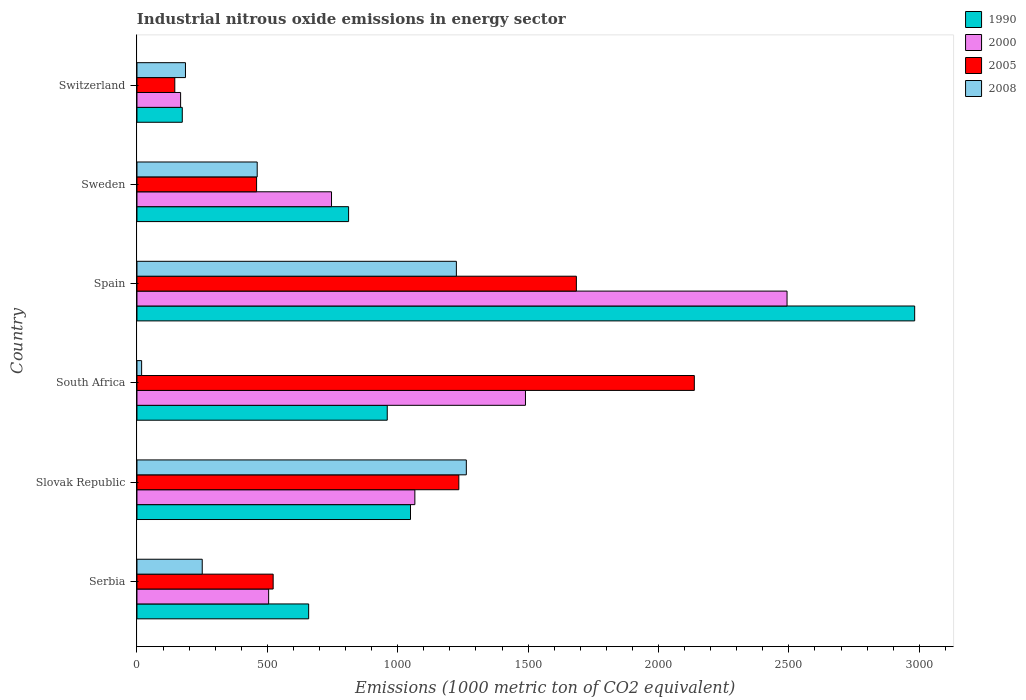How many different coloured bars are there?
Provide a short and direct response. 4. How many groups of bars are there?
Your answer should be very brief. 6. Are the number of bars on each tick of the Y-axis equal?
Keep it short and to the point. Yes. How many bars are there on the 1st tick from the top?
Offer a very short reply. 4. How many bars are there on the 3rd tick from the bottom?
Your answer should be very brief. 4. What is the label of the 1st group of bars from the top?
Give a very brief answer. Switzerland. In how many cases, is the number of bars for a given country not equal to the number of legend labels?
Give a very brief answer. 0. What is the amount of industrial nitrous oxide emitted in 2008 in South Africa?
Offer a terse response. 17.9. Across all countries, what is the maximum amount of industrial nitrous oxide emitted in 2008?
Make the answer very short. 1263.1. Across all countries, what is the minimum amount of industrial nitrous oxide emitted in 1990?
Keep it short and to the point. 173.8. In which country was the amount of industrial nitrous oxide emitted in 2005 maximum?
Give a very brief answer. South Africa. In which country was the amount of industrial nitrous oxide emitted in 2005 minimum?
Offer a terse response. Switzerland. What is the total amount of industrial nitrous oxide emitted in 2005 in the graph?
Offer a very short reply. 6183. What is the difference between the amount of industrial nitrous oxide emitted in 2008 in South Africa and that in Spain?
Provide a succinct answer. -1207. What is the difference between the amount of industrial nitrous oxide emitted in 2005 in Switzerland and the amount of industrial nitrous oxide emitted in 2000 in Spain?
Make the answer very short. -2347.9. What is the average amount of industrial nitrous oxide emitted in 2000 per country?
Offer a terse response. 1077.85. What is the difference between the amount of industrial nitrous oxide emitted in 2000 and amount of industrial nitrous oxide emitted in 2008 in Slovak Republic?
Your answer should be very brief. -197.4. In how many countries, is the amount of industrial nitrous oxide emitted in 2008 greater than 1000 1000 metric ton?
Give a very brief answer. 2. What is the ratio of the amount of industrial nitrous oxide emitted in 1990 in Slovak Republic to that in South Africa?
Make the answer very short. 1.09. Is the difference between the amount of industrial nitrous oxide emitted in 2000 in South Africa and Sweden greater than the difference between the amount of industrial nitrous oxide emitted in 2008 in South Africa and Sweden?
Your answer should be very brief. Yes. What is the difference between the highest and the second highest amount of industrial nitrous oxide emitted in 2000?
Your response must be concise. 1003.1. What is the difference between the highest and the lowest amount of industrial nitrous oxide emitted in 2005?
Provide a succinct answer. 1992.3. In how many countries, is the amount of industrial nitrous oxide emitted in 2000 greater than the average amount of industrial nitrous oxide emitted in 2000 taken over all countries?
Offer a terse response. 2. Is the sum of the amount of industrial nitrous oxide emitted in 1990 in Serbia and Slovak Republic greater than the maximum amount of industrial nitrous oxide emitted in 2005 across all countries?
Provide a succinct answer. No. Is it the case that in every country, the sum of the amount of industrial nitrous oxide emitted in 2000 and amount of industrial nitrous oxide emitted in 2005 is greater than the sum of amount of industrial nitrous oxide emitted in 1990 and amount of industrial nitrous oxide emitted in 2008?
Your answer should be compact. No. What does the 2nd bar from the bottom in Switzerland represents?
Your answer should be very brief. 2000. How many bars are there?
Make the answer very short. 24. How many countries are there in the graph?
Offer a very short reply. 6. What is the difference between two consecutive major ticks on the X-axis?
Ensure brevity in your answer.  500. Does the graph contain grids?
Ensure brevity in your answer.  No. Where does the legend appear in the graph?
Keep it short and to the point. Top right. How many legend labels are there?
Offer a terse response. 4. What is the title of the graph?
Provide a short and direct response. Industrial nitrous oxide emissions in energy sector. What is the label or title of the X-axis?
Offer a very short reply. Emissions (1000 metric ton of CO2 equivalent). What is the label or title of the Y-axis?
Your answer should be compact. Country. What is the Emissions (1000 metric ton of CO2 equivalent) of 1990 in Serbia?
Provide a short and direct response. 658.4. What is the Emissions (1000 metric ton of CO2 equivalent) of 2000 in Serbia?
Offer a very short reply. 505. What is the Emissions (1000 metric ton of CO2 equivalent) in 2005 in Serbia?
Make the answer very short. 522.3. What is the Emissions (1000 metric ton of CO2 equivalent) in 2008 in Serbia?
Your response must be concise. 250.3. What is the Emissions (1000 metric ton of CO2 equivalent) in 1990 in Slovak Republic?
Your answer should be very brief. 1049. What is the Emissions (1000 metric ton of CO2 equivalent) of 2000 in Slovak Republic?
Your answer should be very brief. 1065.7. What is the Emissions (1000 metric ton of CO2 equivalent) in 2005 in Slovak Republic?
Ensure brevity in your answer.  1234.3. What is the Emissions (1000 metric ton of CO2 equivalent) of 2008 in Slovak Republic?
Offer a terse response. 1263.1. What is the Emissions (1000 metric ton of CO2 equivalent) of 1990 in South Africa?
Make the answer very short. 959.8. What is the Emissions (1000 metric ton of CO2 equivalent) of 2000 in South Africa?
Offer a very short reply. 1489.9. What is the Emissions (1000 metric ton of CO2 equivalent) in 2005 in South Africa?
Make the answer very short. 2137.4. What is the Emissions (1000 metric ton of CO2 equivalent) of 2008 in South Africa?
Offer a terse response. 17.9. What is the Emissions (1000 metric ton of CO2 equivalent) of 1990 in Spain?
Offer a terse response. 2982.4. What is the Emissions (1000 metric ton of CO2 equivalent) of 2000 in Spain?
Offer a terse response. 2493. What is the Emissions (1000 metric ton of CO2 equivalent) of 2005 in Spain?
Make the answer very short. 1685.1. What is the Emissions (1000 metric ton of CO2 equivalent) in 2008 in Spain?
Give a very brief answer. 1224.9. What is the Emissions (1000 metric ton of CO2 equivalent) in 1990 in Sweden?
Your response must be concise. 811.6. What is the Emissions (1000 metric ton of CO2 equivalent) in 2000 in Sweden?
Your response must be concise. 746.1. What is the Emissions (1000 metric ton of CO2 equivalent) of 2005 in Sweden?
Offer a terse response. 458.8. What is the Emissions (1000 metric ton of CO2 equivalent) of 2008 in Sweden?
Make the answer very short. 461.1. What is the Emissions (1000 metric ton of CO2 equivalent) in 1990 in Switzerland?
Keep it short and to the point. 173.8. What is the Emissions (1000 metric ton of CO2 equivalent) in 2000 in Switzerland?
Your answer should be very brief. 167.4. What is the Emissions (1000 metric ton of CO2 equivalent) of 2005 in Switzerland?
Your answer should be very brief. 145.1. What is the Emissions (1000 metric ton of CO2 equivalent) in 2008 in Switzerland?
Your response must be concise. 186. Across all countries, what is the maximum Emissions (1000 metric ton of CO2 equivalent) in 1990?
Offer a very short reply. 2982.4. Across all countries, what is the maximum Emissions (1000 metric ton of CO2 equivalent) in 2000?
Your response must be concise. 2493. Across all countries, what is the maximum Emissions (1000 metric ton of CO2 equivalent) in 2005?
Give a very brief answer. 2137.4. Across all countries, what is the maximum Emissions (1000 metric ton of CO2 equivalent) of 2008?
Offer a terse response. 1263.1. Across all countries, what is the minimum Emissions (1000 metric ton of CO2 equivalent) in 1990?
Your response must be concise. 173.8. Across all countries, what is the minimum Emissions (1000 metric ton of CO2 equivalent) of 2000?
Ensure brevity in your answer.  167.4. Across all countries, what is the minimum Emissions (1000 metric ton of CO2 equivalent) of 2005?
Your answer should be very brief. 145.1. What is the total Emissions (1000 metric ton of CO2 equivalent) of 1990 in the graph?
Provide a succinct answer. 6635. What is the total Emissions (1000 metric ton of CO2 equivalent) of 2000 in the graph?
Provide a short and direct response. 6467.1. What is the total Emissions (1000 metric ton of CO2 equivalent) of 2005 in the graph?
Your response must be concise. 6183. What is the total Emissions (1000 metric ton of CO2 equivalent) in 2008 in the graph?
Give a very brief answer. 3403.3. What is the difference between the Emissions (1000 metric ton of CO2 equivalent) of 1990 in Serbia and that in Slovak Republic?
Provide a short and direct response. -390.6. What is the difference between the Emissions (1000 metric ton of CO2 equivalent) of 2000 in Serbia and that in Slovak Republic?
Give a very brief answer. -560.7. What is the difference between the Emissions (1000 metric ton of CO2 equivalent) of 2005 in Serbia and that in Slovak Republic?
Keep it short and to the point. -712. What is the difference between the Emissions (1000 metric ton of CO2 equivalent) in 2008 in Serbia and that in Slovak Republic?
Provide a succinct answer. -1012.8. What is the difference between the Emissions (1000 metric ton of CO2 equivalent) of 1990 in Serbia and that in South Africa?
Make the answer very short. -301.4. What is the difference between the Emissions (1000 metric ton of CO2 equivalent) of 2000 in Serbia and that in South Africa?
Offer a terse response. -984.9. What is the difference between the Emissions (1000 metric ton of CO2 equivalent) in 2005 in Serbia and that in South Africa?
Your answer should be very brief. -1615.1. What is the difference between the Emissions (1000 metric ton of CO2 equivalent) in 2008 in Serbia and that in South Africa?
Your answer should be compact. 232.4. What is the difference between the Emissions (1000 metric ton of CO2 equivalent) of 1990 in Serbia and that in Spain?
Provide a short and direct response. -2324. What is the difference between the Emissions (1000 metric ton of CO2 equivalent) in 2000 in Serbia and that in Spain?
Provide a succinct answer. -1988. What is the difference between the Emissions (1000 metric ton of CO2 equivalent) of 2005 in Serbia and that in Spain?
Ensure brevity in your answer.  -1162.8. What is the difference between the Emissions (1000 metric ton of CO2 equivalent) of 2008 in Serbia and that in Spain?
Ensure brevity in your answer.  -974.6. What is the difference between the Emissions (1000 metric ton of CO2 equivalent) of 1990 in Serbia and that in Sweden?
Your answer should be very brief. -153.2. What is the difference between the Emissions (1000 metric ton of CO2 equivalent) of 2000 in Serbia and that in Sweden?
Give a very brief answer. -241.1. What is the difference between the Emissions (1000 metric ton of CO2 equivalent) of 2005 in Serbia and that in Sweden?
Provide a short and direct response. 63.5. What is the difference between the Emissions (1000 metric ton of CO2 equivalent) of 2008 in Serbia and that in Sweden?
Ensure brevity in your answer.  -210.8. What is the difference between the Emissions (1000 metric ton of CO2 equivalent) of 1990 in Serbia and that in Switzerland?
Provide a succinct answer. 484.6. What is the difference between the Emissions (1000 metric ton of CO2 equivalent) in 2000 in Serbia and that in Switzerland?
Provide a succinct answer. 337.6. What is the difference between the Emissions (1000 metric ton of CO2 equivalent) of 2005 in Serbia and that in Switzerland?
Keep it short and to the point. 377.2. What is the difference between the Emissions (1000 metric ton of CO2 equivalent) of 2008 in Serbia and that in Switzerland?
Your answer should be very brief. 64.3. What is the difference between the Emissions (1000 metric ton of CO2 equivalent) in 1990 in Slovak Republic and that in South Africa?
Your response must be concise. 89.2. What is the difference between the Emissions (1000 metric ton of CO2 equivalent) of 2000 in Slovak Republic and that in South Africa?
Offer a terse response. -424.2. What is the difference between the Emissions (1000 metric ton of CO2 equivalent) of 2005 in Slovak Republic and that in South Africa?
Your response must be concise. -903.1. What is the difference between the Emissions (1000 metric ton of CO2 equivalent) in 2008 in Slovak Republic and that in South Africa?
Your answer should be very brief. 1245.2. What is the difference between the Emissions (1000 metric ton of CO2 equivalent) of 1990 in Slovak Republic and that in Spain?
Provide a succinct answer. -1933.4. What is the difference between the Emissions (1000 metric ton of CO2 equivalent) in 2000 in Slovak Republic and that in Spain?
Make the answer very short. -1427.3. What is the difference between the Emissions (1000 metric ton of CO2 equivalent) in 2005 in Slovak Republic and that in Spain?
Your answer should be very brief. -450.8. What is the difference between the Emissions (1000 metric ton of CO2 equivalent) in 2008 in Slovak Republic and that in Spain?
Keep it short and to the point. 38.2. What is the difference between the Emissions (1000 metric ton of CO2 equivalent) in 1990 in Slovak Republic and that in Sweden?
Your answer should be compact. 237.4. What is the difference between the Emissions (1000 metric ton of CO2 equivalent) of 2000 in Slovak Republic and that in Sweden?
Provide a short and direct response. 319.6. What is the difference between the Emissions (1000 metric ton of CO2 equivalent) of 2005 in Slovak Republic and that in Sweden?
Your answer should be compact. 775.5. What is the difference between the Emissions (1000 metric ton of CO2 equivalent) of 2008 in Slovak Republic and that in Sweden?
Keep it short and to the point. 802. What is the difference between the Emissions (1000 metric ton of CO2 equivalent) of 1990 in Slovak Republic and that in Switzerland?
Provide a short and direct response. 875.2. What is the difference between the Emissions (1000 metric ton of CO2 equivalent) of 2000 in Slovak Republic and that in Switzerland?
Make the answer very short. 898.3. What is the difference between the Emissions (1000 metric ton of CO2 equivalent) in 2005 in Slovak Republic and that in Switzerland?
Ensure brevity in your answer.  1089.2. What is the difference between the Emissions (1000 metric ton of CO2 equivalent) of 2008 in Slovak Republic and that in Switzerland?
Make the answer very short. 1077.1. What is the difference between the Emissions (1000 metric ton of CO2 equivalent) in 1990 in South Africa and that in Spain?
Provide a short and direct response. -2022.6. What is the difference between the Emissions (1000 metric ton of CO2 equivalent) of 2000 in South Africa and that in Spain?
Give a very brief answer. -1003.1. What is the difference between the Emissions (1000 metric ton of CO2 equivalent) of 2005 in South Africa and that in Spain?
Make the answer very short. 452.3. What is the difference between the Emissions (1000 metric ton of CO2 equivalent) of 2008 in South Africa and that in Spain?
Make the answer very short. -1207. What is the difference between the Emissions (1000 metric ton of CO2 equivalent) in 1990 in South Africa and that in Sweden?
Offer a very short reply. 148.2. What is the difference between the Emissions (1000 metric ton of CO2 equivalent) in 2000 in South Africa and that in Sweden?
Provide a succinct answer. 743.8. What is the difference between the Emissions (1000 metric ton of CO2 equivalent) of 2005 in South Africa and that in Sweden?
Provide a succinct answer. 1678.6. What is the difference between the Emissions (1000 metric ton of CO2 equivalent) in 2008 in South Africa and that in Sweden?
Keep it short and to the point. -443.2. What is the difference between the Emissions (1000 metric ton of CO2 equivalent) of 1990 in South Africa and that in Switzerland?
Keep it short and to the point. 786. What is the difference between the Emissions (1000 metric ton of CO2 equivalent) of 2000 in South Africa and that in Switzerland?
Give a very brief answer. 1322.5. What is the difference between the Emissions (1000 metric ton of CO2 equivalent) of 2005 in South Africa and that in Switzerland?
Provide a succinct answer. 1992.3. What is the difference between the Emissions (1000 metric ton of CO2 equivalent) in 2008 in South Africa and that in Switzerland?
Your answer should be very brief. -168.1. What is the difference between the Emissions (1000 metric ton of CO2 equivalent) in 1990 in Spain and that in Sweden?
Make the answer very short. 2170.8. What is the difference between the Emissions (1000 metric ton of CO2 equivalent) in 2000 in Spain and that in Sweden?
Keep it short and to the point. 1746.9. What is the difference between the Emissions (1000 metric ton of CO2 equivalent) of 2005 in Spain and that in Sweden?
Offer a very short reply. 1226.3. What is the difference between the Emissions (1000 metric ton of CO2 equivalent) in 2008 in Spain and that in Sweden?
Offer a very short reply. 763.8. What is the difference between the Emissions (1000 metric ton of CO2 equivalent) in 1990 in Spain and that in Switzerland?
Provide a succinct answer. 2808.6. What is the difference between the Emissions (1000 metric ton of CO2 equivalent) of 2000 in Spain and that in Switzerland?
Your answer should be compact. 2325.6. What is the difference between the Emissions (1000 metric ton of CO2 equivalent) of 2005 in Spain and that in Switzerland?
Provide a succinct answer. 1540. What is the difference between the Emissions (1000 metric ton of CO2 equivalent) of 2008 in Spain and that in Switzerland?
Keep it short and to the point. 1038.9. What is the difference between the Emissions (1000 metric ton of CO2 equivalent) in 1990 in Sweden and that in Switzerland?
Offer a very short reply. 637.8. What is the difference between the Emissions (1000 metric ton of CO2 equivalent) of 2000 in Sweden and that in Switzerland?
Your answer should be very brief. 578.7. What is the difference between the Emissions (1000 metric ton of CO2 equivalent) of 2005 in Sweden and that in Switzerland?
Ensure brevity in your answer.  313.7. What is the difference between the Emissions (1000 metric ton of CO2 equivalent) in 2008 in Sweden and that in Switzerland?
Offer a very short reply. 275.1. What is the difference between the Emissions (1000 metric ton of CO2 equivalent) in 1990 in Serbia and the Emissions (1000 metric ton of CO2 equivalent) in 2000 in Slovak Republic?
Give a very brief answer. -407.3. What is the difference between the Emissions (1000 metric ton of CO2 equivalent) in 1990 in Serbia and the Emissions (1000 metric ton of CO2 equivalent) in 2005 in Slovak Republic?
Your answer should be very brief. -575.9. What is the difference between the Emissions (1000 metric ton of CO2 equivalent) of 1990 in Serbia and the Emissions (1000 metric ton of CO2 equivalent) of 2008 in Slovak Republic?
Offer a very short reply. -604.7. What is the difference between the Emissions (1000 metric ton of CO2 equivalent) of 2000 in Serbia and the Emissions (1000 metric ton of CO2 equivalent) of 2005 in Slovak Republic?
Ensure brevity in your answer.  -729.3. What is the difference between the Emissions (1000 metric ton of CO2 equivalent) of 2000 in Serbia and the Emissions (1000 metric ton of CO2 equivalent) of 2008 in Slovak Republic?
Keep it short and to the point. -758.1. What is the difference between the Emissions (1000 metric ton of CO2 equivalent) of 2005 in Serbia and the Emissions (1000 metric ton of CO2 equivalent) of 2008 in Slovak Republic?
Offer a very short reply. -740.8. What is the difference between the Emissions (1000 metric ton of CO2 equivalent) in 1990 in Serbia and the Emissions (1000 metric ton of CO2 equivalent) in 2000 in South Africa?
Your answer should be compact. -831.5. What is the difference between the Emissions (1000 metric ton of CO2 equivalent) of 1990 in Serbia and the Emissions (1000 metric ton of CO2 equivalent) of 2005 in South Africa?
Provide a succinct answer. -1479. What is the difference between the Emissions (1000 metric ton of CO2 equivalent) in 1990 in Serbia and the Emissions (1000 metric ton of CO2 equivalent) in 2008 in South Africa?
Provide a succinct answer. 640.5. What is the difference between the Emissions (1000 metric ton of CO2 equivalent) in 2000 in Serbia and the Emissions (1000 metric ton of CO2 equivalent) in 2005 in South Africa?
Provide a succinct answer. -1632.4. What is the difference between the Emissions (1000 metric ton of CO2 equivalent) of 2000 in Serbia and the Emissions (1000 metric ton of CO2 equivalent) of 2008 in South Africa?
Provide a succinct answer. 487.1. What is the difference between the Emissions (1000 metric ton of CO2 equivalent) in 2005 in Serbia and the Emissions (1000 metric ton of CO2 equivalent) in 2008 in South Africa?
Make the answer very short. 504.4. What is the difference between the Emissions (1000 metric ton of CO2 equivalent) of 1990 in Serbia and the Emissions (1000 metric ton of CO2 equivalent) of 2000 in Spain?
Ensure brevity in your answer.  -1834.6. What is the difference between the Emissions (1000 metric ton of CO2 equivalent) of 1990 in Serbia and the Emissions (1000 metric ton of CO2 equivalent) of 2005 in Spain?
Your answer should be compact. -1026.7. What is the difference between the Emissions (1000 metric ton of CO2 equivalent) in 1990 in Serbia and the Emissions (1000 metric ton of CO2 equivalent) in 2008 in Spain?
Offer a terse response. -566.5. What is the difference between the Emissions (1000 metric ton of CO2 equivalent) of 2000 in Serbia and the Emissions (1000 metric ton of CO2 equivalent) of 2005 in Spain?
Give a very brief answer. -1180.1. What is the difference between the Emissions (1000 metric ton of CO2 equivalent) in 2000 in Serbia and the Emissions (1000 metric ton of CO2 equivalent) in 2008 in Spain?
Make the answer very short. -719.9. What is the difference between the Emissions (1000 metric ton of CO2 equivalent) in 2005 in Serbia and the Emissions (1000 metric ton of CO2 equivalent) in 2008 in Spain?
Offer a very short reply. -702.6. What is the difference between the Emissions (1000 metric ton of CO2 equivalent) in 1990 in Serbia and the Emissions (1000 metric ton of CO2 equivalent) in 2000 in Sweden?
Your response must be concise. -87.7. What is the difference between the Emissions (1000 metric ton of CO2 equivalent) of 1990 in Serbia and the Emissions (1000 metric ton of CO2 equivalent) of 2005 in Sweden?
Give a very brief answer. 199.6. What is the difference between the Emissions (1000 metric ton of CO2 equivalent) in 1990 in Serbia and the Emissions (1000 metric ton of CO2 equivalent) in 2008 in Sweden?
Offer a very short reply. 197.3. What is the difference between the Emissions (1000 metric ton of CO2 equivalent) of 2000 in Serbia and the Emissions (1000 metric ton of CO2 equivalent) of 2005 in Sweden?
Provide a succinct answer. 46.2. What is the difference between the Emissions (1000 metric ton of CO2 equivalent) of 2000 in Serbia and the Emissions (1000 metric ton of CO2 equivalent) of 2008 in Sweden?
Your answer should be compact. 43.9. What is the difference between the Emissions (1000 metric ton of CO2 equivalent) in 2005 in Serbia and the Emissions (1000 metric ton of CO2 equivalent) in 2008 in Sweden?
Keep it short and to the point. 61.2. What is the difference between the Emissions (1000 metric ton of CO2 equivalent) of 1990 in Serbia and the Emissions (1000 metric ton of CO2 equivalent) of 2000 in Switzerland?
Provide a succinct answer. 491. What is the difference between the Emissions (1000 metric ton of CO2 equivalent) in 1990 in Serbia and the Emissions (1000 metric ton of CO2 equivalent) in 2005 in Switzerland?
Keep it short and to the point. 513.3. What is the difference between the Emissions (1000 metric ton of CO2 equivalent) in 1990 in Serbia and the Emissions (1000 metric ton of CO2 equivalent) in 2008 in Switzerland?
Your answer should be very brief. 472.4. What is the difference between the Emissions (1000 metric ton of CO2 equivalent) in 2000 in Serbia and the Emissions (1000 metric ton of CO2 equivalent) in 2005 in Switzerland?
Offer a terse response. 359.9. What is the difference between the Emissions (1000 metric ton of CO2 equivalent) of 2000 in Serbia and the Emissions (1000 metric ton of CO2 equivalent) of 2008 in Switzerland?
Your response must be concise. 319. What is the difference between the Emissions (1000 metric ton of CO2 equivalent) in 2005 in Serbia and the Emissions (1000 metric ton of CO2 equivalent) in 2008 in Switzerland?
Your answer should be very brief. 336.3. What is the difference between the Emissions (1000 metric ton of CO2 equivalent) in 1990 in Slovak Republic and the Emissions (1000 metric ton of CO2 equivalent) in 2000 in South Africa?
Give a very brief answer. -440.9. What is the difference between the Emissions (1000 metric ton of CO2 equivalent) of 1990 in Slovak Republic and the Emissions (1000 metric ton of CO2 equivalent) of 2005 in South Africa?
Make the answer very short. -1088.4. What is the difference between the Emissions (1000 metric ton of CO2 equivalent) of 1990 in Slovak Republic and the Emissions (1000 metric ton of CO2 equivalent) of 2008 in South Africa?
Offer a very short reply. 1031.1. What is the difference between the Emissions (1000 metric ton of CO2 equivalent) in 2000 in Slovak Republic and the Emissions (1000 metric ton of CO2 equivalent) in 2005 in South Africa?
Provide a short and direct response. -1071.7. What is the difference between the Emissions (1000 metric ton of CO2 equivalent) of 2000 in Slovak Republic and the Emissions (1000 metric ton of CO2 equivalent) of 2008 in South Africa?
Offer a very short reply. 1047.8. What is the difference between the Emissions (1000 metric ton of CO2 equivalent) in 2005 in Slovak Republic and the Emissions (1000 metric ton of CO2 equivalent) in 2008 in South Africa?
Give a very brief answer. 1216.4. What is the difference between the Emissions (1000 metric ton of CO2 equivalent) in 1990 in Slovak Republic and the Emissions (1000 metric ton of CO2 equivalent) in 2000 in Spain?
Your response must be concise. -1444. What is the difference between the Emissions (1000 metric ton of CO2 equivalent) of 1990 in Slovak Republic and the Emissions (1000 metric ton of CO2 equivalent) of 2005 in Spain?
Make the answer very short. -636.1. What is the difference between the Emissions (1000 metric ton of CO2 equivalent) in 1990 in Slovak Republic and the Emissions (1000 metric ton of CO2 equivalent) in 2008 in Spain?
Offer a very short reply. -175.9. What is the difference between the Emissions (1000 metric ton of CO2 equivalent) of 2000 in Slovak Republic and the Emissions (1000 metric ton of CO2 equivalent) of 2005 in Spain?
Offer a very short reply. -619.4. What is the difference between the Emissions (1000 metric ton of CO2 equivalent) in 2000 in Slovak Republic and the Emissions (1000 metric ton of CO2 equivalent) in 2008 in Spain?
Provide a succinct answer. -159.2. What is the difference between the Emissions (1000 metric ton of CO2 equivalent) of 1990 in Slovak Republic and the Emissions (1000 metric ton of CO2 equivalent) of 2000 in Sweden?
Your answer should be very brief. 302.9. What is the difference between the Emissions (1000 metric ton of CO2 equivalent) in 1990 in Slovak Republic and the Emissions (1000 metric ton of CO2 equivalent) in 2005 in Sweden?
Provide a succinct answer. 590.2. What is the difference between the Emissions (1000 metric ton of CO2 equivalent) of 1990 in Slovak Republic and the Emissions (1000 metric ton of CO2 equivalent) of 2008 in Sweden?
Ensure brevity in your answer.  587.9. What is the difference between the Emissions (1000 metric ton of CO2 equivalent) of 2000 in Slovak Republic and the Emissions (1000 metric ton of CO2 equivalent) of 2005 in Sweden?
Your answer should be very brief. 606.9. What is the difference between the Emissions (1000 metric ton of CO2 equivalent) of 2000 in Slovak Republic and the Emissions (1000 metric ton of CO2 equivalent) of 2008 in Sweden?
Your response must be concise. 604.6. What is the difference between the Emissions (1000 metric ton of CO2 equivalent) of 2005 in Slovak Republic and the Emissions (1000 metric ton of CO2 equivalent) of 2008 in Sweden?
Provide a succinct answer. 773.2. What is the difference between the Emissions (1000 metric ton of CO2 equivalent) in 1990 in Slovak Republic and the Emissions (1000 metric ton of CO2 equivalent) in 2000 in Switzerland?
Make the answer very short. 881.6. What is the difference between the Emissions (1000 metric ton of CO2 equivalent) of 1990 in Slovak Republic and the Emissions (1000 metric ton of CO2 equivalent) of 2005 in Switzerland?
Your answer should be very brief. 903.9. What is the difference between the Emissions (1000 metric ton of CO2 equivalent) of 1990 in Slovak Republic and the Emissions (1000 metric ton of CO2 equivalent) of 2008 in Switzerland?
Your answer should be very brief. 863. What is the difference between the Emissions (1000 metric ton of CO2 equivalent) of 2000 in Slovak Republic and the Emissions (1000 metric ton of CO2 equivalent) of 2005 in Switzerland?
Your response must be concise. 920.6. What is the difference between the Emissions (1000 metric ton of CO2 equivalent) of 2000 in Slovak Republic and the Emissions (1000 metric ton of CO2 equivalent) of 2008 in Switzerland?
Provide a short and direct response. 879.7. What is the difference between the Emissions (1000 metric ton of CO2 equivalent) in 2005 in Slovak Republic and the Emissions (1000 metric ton of CO2 equivalent) in 2008 in Switzerland?
Give a very brief answer. 1048.3. What is the difference between the Emissions (1000 metric ton of CO2 equivalent) of 1990 in South Africa and the Emissions (1000 metric ton of CO2 equivalent) of 2000 in Spain?
Provide a succinct answer. -1533.2. What is the difference between the Emissions (1000 metric ton of CO2 equivalent) of 1990 in South Africa and the Emissions (1000 metric ton of CO2 equivalent) of 2005 in Spain?
Give a very brief answer. -725.3. What is the difference between the Emissions (1000 metric ton of CO2 equivalent) in 1990 in South Africa and the Emissions (1000 metric ton of CO2 equivalent) in 2008 in Spain?
Provide a short and direct response. -265.1. What is the difference between the Emissions (1000 metric ton of CO2 equivalent) in 2000 in South Africa and the Emissions (1000 metric ton of CO2 equivalent) in 2005 in Spain?
Your answer should be compact. -195.2. What is the difference between the Emissions (1000 metric ton of CO2 equivalent) of 2000 in South Africa and the Emissions (1000 metric ton of CO2 equivalent) of 2008 in Spain?
Offer a terse response. 265. What is the difference between the Emissions (1000 metric ton of CO2 equivalent) of 2005 in South Africa and the Emissions (1000 metric ton of CO2 equivalent) of 2008 in Spain?
Ensure brevity in your answer.  912.5. What is the difference between the Emissions (1000 metric ton of CO2 equivalent) in 1990 in South Africa and the Emissions (1000 metric ton of CO2 equivalent) in 2000 in Sweden?
Ensure brevity in your answer.  213.7. What is the difference between the Emissions (1000 metric ton of CO2 equivalent) in 1990 in South Africa and the Emissions (1000 metric ton of CO2 equivalent) in 2005 in Sweden?
Offer a terse response. 501. What is the difference between the Emissions (1000 metric ton of CO2 equivalent) of 1990 in South Africa and the Emissions (1000 metric ton of CO2 equivalent) of 2008 in Sweden?
Keep it short and to the point. 498.7. What is the difference between the Emissions (1000 metric ton of CO2 equivalent) in 2000 in South Africa and the Emissions (1000 metric ton of CO2 equivalent) in 2005 in Sweden?
Ensure brevity in your answer.  1031.1. What is the difference between the Emissions (1000 metric ton of CO2 equivalent) of 2000 in South Africa and the Emissions (1000 metric ton of CO2 equivalent) of 2008 in Sweden?
Offer a very short reply. 1028.8. What is the difference between the Emissions (1000 metric ton of CO2 equivalent) in 2005 in South Africa and the Emissions (1000 metric ton of CO2 equivalent) in 2008 in Sweden?
Provide a succinct answer. 1676.3. What is the difference between the Emissions (1000 metric ton of CO2 equivalent) in 1990 in South Africa and the Emissions (1000 metric ton of CO2 equivalent) in 2000 in Switzerland?
Ensure brevity in your answer.  792.4. What is the difference between the Emissions (1000 metric ton of CO2 equivalent) of 1990 in South Africa and the Emissions (1000 metric ton of CO2 equivalent) of 2005 in Switzerland?
Give a very brief answer. 814.7. What is the difference between the Emissions (1000 metric ton of CO2 equivalent) in 1990 in South Africa and the Emissions (1000 metric ton of CO2 equivalent) in 2008 in Switzerland?
Ensure brevity in your answer.  773.8. What is the difference between the Emissions (1000 metric ton of CO2 equivalent) in 2000 in South Africa and the Emissions (1000 metric ton of CO2 equivalent) in 2005 in Switzerland?
Make the answer very short. 1344.8. What is the difference between the Emissions (1000 metric ton of CO2 equivalent) in 2000 in South Africa and the Emissions (1000 metric ton of CO2 equivalent) in 2008 in Switzerland?
Your answer should be very brief. 1303.9. What is the difference between the Emissions (1000 metric ton of CO2 equivalent) in 2005 in South Africa and the Emissions (1000 metric ton of CO2 equivalent) in 2008 in Switzerland?
Your response must be concise. 1951.4. What is the difference between the Emissions (1000 metric ton of CO2 equivalent) of 1990 in Spain and the Emissions (1000 metric ton of CO2 equivalent) of 2000 in Sweden?
Provide a short and direct response. 2236.3. What is the difference between the Emissions (1000 metric ton of CO2 equivalent) in 1990 in Spain and the Emissions (1000 metric ton of CO2 equivalent) in 2005 in Sweden?
Your answer should be very brief. 2523.6. What is the difference between the Emissions (1000 metric ton of CO2 equivalent) in 1990 in Spain and the Emissions (1000 metric ton of CO2 equivalent) in 2008 in Sweden?
Provide a short and direct response. 2521.3. What is the difference between the Emissions (1000 metric ton of CO2 equivalent) in 2000 in Spain and the Emissions (1000 metric ton of CO2 equivalent) in 2005 in Sweden?
Your answer should be compact. 2034.2. What is the difference between the Emissions (1000 metric ton of CO2 equivalent) in 2000 in Spain and the Emissions (1000 metric ton of CO2 equivalent) in 2008 in Sweden?
Give a very brief answer. 2031.9. What is the difference between the Emissions (1000 metric ton of CO2 equivalent) in 2005 in Spain and the Emissions (1000 metric ton of CO2 equivalent) in 2008 in Sweden?
Offer a very short reply. 1224. What is the difference between the Emissions (1000 metric ton of CO2 equivalent) of 1990 in Spain and the Emissions (1000 metric ton of CO2 equivalent) of 2000 in Switzerland?
Your response must be concise. 2815. What is the difference between the Emissions (1000 metric ton of CO2 equivalent) in 1990 in Spain and the Emissions (1000 metric ton of CO2 equivalent) in 2005 in Switzerland?
Keep it short and to the point. 2837.3. What is the difference between the Emissions (1000 metric ton of CO2 equivalent) of 1990 in Spain and the Emissions (1000 metric ton of CO2 equivalent) of 2008 in Switzerland?
Keep it short and to the point. 2796.4. What is the difference between the Emissions (1000 metric ton of CO2 equivalent) of 2000 in Spain and the Emissions (1000 metric ton of CO2 equivalent) of 2005 in Switzerland?
Your answer should be compact. 2347.9. What is the difference between the Emissions (1000 metric ton of CO2 equivalent) of 2000 in Spain and the Emissions (1000 metric ton of CO2 equivalent) of 2008 in Switzerland?
Your response must be concise. 2307. What is the difference between the Emissions (1000 metric ton of CO2 equivalent) of 2005 in Spain and the Emissions (1000 metric ton of CO2 equivalent) of 2008 in Switzerland?
Your answer should be compact. 1499.1. What is the difference between the Emissions (1000 metric ton of CO2 equivalent) in 1990 in Sweden and the Emissions (1000 metric ton of CO2 equivalent) in 2000 in Switzerland?
Your answer should be very brief. 644.2. What is the difference between the Emissions (1000 metric ton of CO2 equivalent) in 1990 in Sweden and the Emissions (1000 metric ton of CO2 equivalent) in 2005 in Switzerland?
Provide a short and direct response. 666.5. What is the difference between the Emissions (1000 metric ton of CO2 equivalent) of 1990 in Sweden and the Emissions (1000 metric ton of CO2 equivalent) of 2008 in Switzerland?
Keep it short and to the point. 625.6. What is the difference between the Emissions (1000 metric ton of CO2 equivalent) of 2000 in Sweden and the Emissions (1000 metric ton of CO2 equivalent) of 2005 in Switzerland?
Make the answer very short. 601. What is the difference between the Emissions (1000 metric ton of CO2 equivalent) of 2000 in Sweden and the Emissions (1000 metric ton of CO2 equivalent) of 2008 in Switzerland?
Your response must be concise. 560.1. What is the difference between the Emissions (1000 metric ton of CO2 equivalent) of 2005 in Sweden and the Emissions (1000 metric ton of CO2 equivalent) of 2008 in Switzerland?
Provide a succinct answer. 272.8. What is the average Emissions (1000 metric ton of CO2 equivalent) of 1990 per country?
Your response must be concise. 1105.83. What is the average Emissions (1000 metric ton of CO2 equivalent) of 2000 per country?
Ensure brevity in your answer.  1077.85. What is the average Emissions (1000 metric ton of CO2 equivalent) of 2005 per country?
Offer a terse response. 1030.5. What is the average Emissions (1000 metric ton of CO2 equivalent) in 2008 per country?
Offer a very short reply. 567.22. What is the difference between the Emissions (1000 metric ton of CO2 equivalent) in 1990 and Emissions (1000 metric ton of CO2 equivalent) in 2000 in Serbia?
Keep it short and to the point. 153.4. What is the difference between the Emissions (1000 metric ton of CO2 equivalent) in 1990 and Emissions (1000 metric ton of CO2 equivalent) in 2005 in Serbia?
Your answer should be compact. 136.1. What is the difference between the Emissions (1000 metric ton of CO2 equivalent) of 1990 and Emissions (1000 metric ton of CO2 equivalent) of 2008 in Serbia?
Ensure brevity in your answer.  408.1. What is the difference between the Emissions (1000 metric ton of CO2 equivalent) in 2000 and Emissions (1000 metric ton of CO2 equivalent) in 2005 in Serbia?
Make the answer very short. -17.3. What is the difference between the Emissions (1000 metric ton of CO2 equivalent) of 2000 and Emissions (1000 metric ton of CO2 equivalent) of 2008 in Serbia?
Your answer should be very brief. 254.7. What is the difference between the Emissions (1000 metric ton of CO2 equivalent) of 2005 and Emissions (1000 metric ton of CO2 equivalent) of 2008 in Serbia?
Your answer should be very brief. 272. What is the difference between the Emissions (1000 metric ton of CO2 equivalent) of 1990 and Emissions (1000 metric ton of CO2 equivalent) of 2000 in Slovak Republic?
Your answer should be compact. -16.7. What is the difference between the Emissions (1000 metric ton of CO2 equivalent) in 1990 and Emissions (1000 metric ton of CO2 equivalent) in 2005 in Slovak Republic?
Your answer should be compact. -185.3. What is the difference between the Emissions (1000 metric ton of CO2 equivalent) in 1990 and Emissions (1000 metric ton of CO2 equivalent) in 2008 in Slovak Republic?
Provide a short and direct response. -214.1. What is the difference between the Emissions (1000 metric ton of CO2 equivalent) of 2000 and Emissions (1000 metric ton of CO2 equivalent) of 2005 in Slovak Republic?
Your response must be concise. -168.6. What is the difference between the Emissions (1000 metric ton of CO2 equivalent) in 2000 and Emissions (1000 metric ton of CO2 equivalent) in 2008 in Slovak Republic?
Provide a short and direct response. -197.4. What is the difference between the Emissions (1000 metric ton of CO2 equivalent) of 2005 and Emissions (1000 metric ton of CO2 equivalent) of 2008 in Slovak Republic?
Ensure brevity in your answer.  -28.8. What is the difference between the Emissions (1000 metric ton of CO2 equivalent) in 1990 and Emissions (1000 metric ton of CO2 equivalent) in 2000 in South Africa?
Your response must be concise. -530.1. What is the difference between the Emissions (1000 metric ton of CO2 equivalent) in 1990 and Emissions (1000 metric ton of CO2 equivalent) in 2005 in South Africa?
Make the answer very short. -1177.6. What is the difference between the Emissions (1000 metric ton of CO2 equivalent) of 1990 and Emissions (1000 metric ton of CO2 equivalent) of 2008 in South Africa?
Your response must be concise. 941.9. What is the difference between the Emissions (1000 metric ton of CO2 equivalent) of 2000 and Emissions (1000 metric ton of CO2 equivalent) of 2005 in South Africa?
Offer a terse response. -647.5. What is the difference between the Emissions (1000 metric ton of CO2 equivalent) in 2000 and Emissions (1000 metric ton of CO2 equivalent) in 2008 in South Africa?
Your answer should be compact. 1472. What is the difference between the Emissions (1000 metric ton of CO2 equivalent) of 2005 and Emissions (1000 metric ton of CO2 equivalent) of 2008 in South Africa?
Provide a succinct answer. 2119.5. What is the difference between the Emissions (1000 metric ton of CO2 equivalent) in 1990 and Emissions (1000 metric ton of CO2 equivalent) in 2000 in Spain?
Your answer should be very brief. 489.4. What is the difference between the Emissions (1000 metric ton of CO2 equivalent) in 1990 and Emissions (1000 metric ton of CO2 equivalent) in 2005 in Spain?
Give a very brief answer. 1297.3. What is the difference between the Emissions (1000 metric ton of CO2 equivalent) of 1990 and Emissions (1000 metric ton of CO2 equivalent) of 2008 in Spain?
Your answer should be very brief. 1757.5. What is the difference between the Emissions (1000 metric ton of CO2 equivalent) of 2000 and Emissions (1000 metric ton of CO2 equivalent) of 2005 in Spain?
Provide a short and direct response. 807.9. What is the difference between the Emissions (1000 metric ton of CO2 equivalent) in 2000 and Emissions (1000 metric ton of CO2 equivalent) in 2008 in Spain?
Your answer should be very brief. 1268.1. What is the difference between the Emissions (1000 metric ton of CO2 equivalent) in 2005 and Emissions (1000 metric ton of CO2 equivalent) in 2008 in Spain?
Offer a very short reply. 460.2. What is the difference between the Emissions (1000 metric ton of CO2 equivalent) of 1990 and Emissions (1000 metric ton of CO2 equivalent) of 2000 in Sweden?
Your response must be concise. 65.5. What is the difference between the Emissions (1000 metric ton of CO2 equivalent) of 1990 and Emissions (1000 metric ton of CO2 equivalent) of 2005 in Sweden?
Provide a succinct answer. 352.8. What is the difference between the Emissions (1000 metric ton of CO2 equivalent) of 1990 and Emissions (1000 metric ton of CO2 equivalent) of 2008 in Sweden?
Ensure brevity in your answer.  350.5. What is the difference between the Emissions (1000 metric ton of CO2 equivalent) in 2000 and Emissions (1000 metric ton of CO2 equivalent) in 2005 in Sweden?
Make the answer very short. 287.3. What is the difference between the Emissions (1000 metric ton of CO2 equivalent) in 2000 and Emissions (1000 metric ton of CO2 equivalent) in 2008 in Sweden?
Make the answer very short. 285. What is the difference between the Emissions (1000 metric ton of CO2 equivalent) of 2005 and Emissions (1000 metric ton of CO2 equivalent) of 2008 in Sweden?
Ensure brevity in your answer.  -2.3. What is the difference between the Emissions (1000 metric ton of CO2 equivalent) in 1990 and Emissions (1000 metric ton of CO2 equivalent) in 2000 in Switzerland?
Give a very brief answer. 6.4. What is the difference between the Emissions (1000 metric ton of CO2 equivalent) of 1990 and Emissions (1000 metric ton of CO2 equivalent) of 2005 in Switzerland?
Offer a terse response. 28.7. What is the difference between the Emissions (1000 metric ton of CO2 equivalent) in 2000 and Emissions (1000 metric ton of CO2 equivalent) in 2005 in Switzerland?
Keep it short and to the point. 22.3. What is the difference between the Emissions (1000 metric ton of CO2 equivalent) in 2000 and Emissions (1000 metric ton of CO2 equivalent) in 2008 in Switzerland?
Keep it short and to the point. -18.6. What is the difference between the Emissions (1000 metric ton of CO2 equivalent) in 2005 and Emissions (1000 metric ton of CO2 equivalent) in 2008 in Switzerland?
Offer a terse response. -40.9. What is the ratio of the Emissions (1000 metric ton of CO2 equivalent) in 1990 in Serbia to that in Slovak Republic?
Your answer should be very brief. 0.63. What is the ratio of the Emissions (1000 metric ton of CO2 equivalent) in 2000 in Serbia to that in Slovak Republic?
Offer a terse response. 0.47. What is the ratio of the Emissions (1000 metric ton of CO2 equivalent) in 2005 in Serbia to that in Slovak Republic?
Provide a succinct answer. 0.42. What is the ratio of the Emissions (1000 metric ton of CO2 equivalent) in 2008 in Serbia to that in Slovak Republic?
Your answer should be compact. 0.2. What is the ratio of the Emissions (1000 metric ton of CO2 equivalent) in 1990 in Serbia to that in South Africa?
Offer a very short reply. 0.69. What is the ratio of the Emissions (1000 metric ton of CO2 equivalent) in 2000 in Serbia to that in South Africa?
Provide a short and direct response. 0.34. What is the ratio of the Emissions (1000 metric ton of CO2 equivalent) in 2005 in Serbia to that in South Africa?
Ensure brevity in your answer.  0.24. What is the ratio of the Emissions (1000 metric ton of CO2 equivalent) of 2008 in Serbia to that in South Africa?
Your answer should be compact. 13.98. What is the ratio of the Emissions (1000 metric ton of CO2 equivalent) of 1990 in Serbia to that in Spain?
Make the answer very short. 0.22. What is the ratio of the Emissions (1000 metric ton of CO2 equivalent) in 2000 in Serbia to that in Spain?
Offer a very short reply. 0.2. What is the ratio of the Emissions (1000 metric ton of CO2 equivalent) of 2005 in Serbia to that in Spain?
Give a very brief answer. 0.31. What is the ratio of the Emissions (1000 metric ton of CO2 equivalent) of 2008 in Serbia to that in Spain?
Offer a very short reply. 0.2. What is the ratio of the Emissions (1000 metric ton of CO2 equivalent) of 1990 in Serbia to that in Sweden?
Keep it short and to the point. 0.81. What is the ratio of the Emissions (1000 metric ton of CO2 equivalent) of 2000 in Serbia to that in Sweden?
Your answer should be very brief. 0.68. What is the ratio of the Emissions (1000 metric ton of CO2 equivalent) in 2005 in Serbia to that in Sweden?
Keep it short and to the point. 1.14. What is the ratio of the Emissions (1000 metric ton of CO2 equivalent) of 2008 in Serbia to that in Sweden?
Offer a terse response. 0.54. What is the ratio of the Emissions (1000 metric ton of CO2 equivalent) of 1990 in Serbia to that in Switzerland?
Provide a succinct answer. 3.79. What is the ratio of the Emissions (1000 metric ton of CO2 equivalent) in 2000 in Serbia to that in Switzerland?
Ensure brevity in your answer.  3.02. What is the ratio of the Emissions (1000 metric ton of CO2 equivalent) in 2005 in Serbia to that in Switzerland?
Offer a very short reply. 3.6. What is the ratio of the Emissions (1000 metric ton of CO2 equivalent) of 2008 in Serbia to that in Switzerland?
Your answer should be very brief. 1.35. What is the ratio of the Emissions (1000 metric ton of CO2 equivalent) in 1990 in Slovak Republic to that in South Africa?
Provide a succinct answer. 1.09. What is the ratio of the Emissions (1000 metric ton of CO2 equivalent) in 2000 in Slovak Republic to that in South Africa?
Your answer should be compact. 0.72. What is the ratio of the Emissions (1000 metric ton of CO2 equivalent) in 2005 in Slovak Republic to that in South Africa?
Ensure brevity in your answer.  0.58. What is the ratio of the Emissions (1000 metric ton of CO2 equivalent) in 2008 in Slovak Republic to that in South Africa?
Your answer should be very brief. 70.56. What is the ratio of the Emissions (1000 metric ton of CO2 equivalent) of 1990 in Slovak Republic to that in Spain?
Give a very brief answer. 0.35. What is the ratio of the Emissions (1000 metric ton of CO2 equivalent) in 2000 in Slovak Republic to that in Spain?
Provide a short and direct response. 0.43. What is the ratio of the Emissions (1000 metric ton of CO2 equivalent) in 2005 in Slovak Republic to that in Spain?
Give a very brief answer. 0.73. What is the ratio of the Emissions (1000 metric ton of CO2 equivalent) in 2008 in Slovak Republic to that in Spain?
Make the answer very short. 1.03. What is the ratio of the Emissions (1000 metric ton of CO2 equivalent) of 1990 in Slovak Republic to that in Sweden?
Ensure brevity in your answer.  1.29. What is the ratio of the Emissions (1000 metric ton of CO2 equivalent) of 2000 in Slovak Republic to that in Sweden?
Ensure brevity in your answer.  1.43. What is the ratio of the Emissions (1000 metric ton of CO2 equivalent) of 2005 in Slovak Republic to that in Sweden?
Your response must be concise. 2.69. What is the ratio of the Emissions (1000 metric ton of CO2 equivalent) in 2008 in Slovak Republic to that in Sweden?
Your answer should be compact. 2.74. What is the ratio of the Emissions (1000 metric ton of CO2 equivalent) of 1990 in Slovak Republic to that in Switzerland?
Provide a succinct answer. 6.04. What is the ratio of the Emissions (1000 metric ton of CO2 equivalent) of 2000 in Slovak Republic to that in Switzerland?
Ensure brevity in your answer.  6.37. What is the ratio of the Emissions (1000 metric ton of CO2 equivalent) in 2005 in Slovak Republic to that in Switzerland?
Keep it short and to the point. 8.51. What is the ratio of the Emissions (1000 metric ton of CO2 equivalent) in 2008 in Slovak Republic to that in Switzerland?
Offer a terse response. 6.79. What is the ratio of the Emissions (1000 metric ton of CO2 equivalent) of 1990 in South Africa to that in Spain?
Provide a short and direct response. 0.32. What is the ratio of the Emissions (1000 metric ton of CO2 equivalent) of 2000 in South Africa to that in Spain?
Your answer should be very brief. 0.6. What is the ratio of the Emissions (1000 metric ton of CO2 equivalent) of 2005 in South Africa to that in Spain?
Provide a short and direct response. 1.27. What is the ratio of the Emissions (1000 metric ton of CO2 equivalent) in 2008 in South Africa to that in Spain?
Provide a succinct answer. 0.01. What is the ratio of the Emissions (1000 metric ton of CO2 equivalent) in 1990 in South Africa to that in Sweden?
Make the answer very short. 1.18. What is the ratio of the Emissions (1000 metric ton of CO2 equivalent) in 2000 in South Africa to that in Sweden?
Your response must be concise. 2. What is the ratio of the Emissions (1000 metric ton of CO2 equivalent) in 2005 in South Africa to that in Sweden?
Offer a terse response. 4.66. What is the ratio of the Emissions (1000 metric ton of CO2 equivalent) of 2008 in South Africa to that in Sweden?
Offer a very short reply. 0.04. What is the ratio of the Emissions (1000 metric ton of CO2 equivalent) of 1990 in South Africa to that in Switzerland?
Give a very brief answer. 5.52. What is the ratio of the Emissions (1000 metric ton of CO2 equivalent) in 2000 in South Africa to that in Switzerland?
Provide a succinct answer. 8.9. What is the ratio of the Emissions (1000 metric ton of CO2 equivalent) in 2005 in South Africa to that in Switzerland?
Ensure brevity in your answer.  14.73. What is the ratio of the Emissions (1000 metric ton of CO2 equivalent) in 2008 in South Africa to that in Switzerland?
Keep it short and to the point. 0.1. What is the ratio of the Emissions (1000 metric ton of CO2 equivalent) in 1990 in Spain to that in Sweden?
Keep it short and to the point. 3.67. What is the ratio of the Emissions (1000 metric ton of CO2 equivalent) in 2000 in Spain to that in Sweden?
Your answer should be very brief. 3.34. What is the ratio of the Emissions (1000 metric ton of CO2 equivalent) of 2005 in Spain to that in Sweden?
Your answer should be very brief. 3.67. What is the ratio of the Emissions (1000 metric ton of CO2 equivalent) in 2008 in Spain to that in Sweden?
Offer a very short reply. 2.66. What is the ratio of the Emissions (1000 metric ton of CO2 equivalent) of 1990 in Spain to that in Switzerland?
Your answer should be compact. 17.16. What is the ratio of the Emissions (1000 metric ton of CO2 equivalent) of 2000 in Spain to that in Switzerland?
Make the answer very short. 14.89. What is the ratio of the Emissions (1000 metric ton of CO2 equivalent) of 2005 in Spain to that in Switzerland?
Provide a short and direct response. 11.61. What is the ratio of the Emissions (1000 metric ton of CO2 equivalent) of 2008 in Spain to that in Switzerland?
Your response must be concise. 6.59. What is the ratio of the Emissions (1000 metric ton of CO2 equivalent) of 1990 in Sweden to that in Switzerland?
Your answer should be compact. 4.67. What is the ratio of the Emissions (1000 metric ton of CO2 equivalent) in 2000 in Sweden to that in Switzerland?
Your response must be concise. 4.46. What is the ratio of the Emissions (1000 metric ton of CO2 equivalent) of 2005 in Sweden to that in Switzerland?
Your answer should be compact. 3.16. What is the ratio of the Emissions (1000 metric ton of CO2 equivalent) in 2008 in Sweden to that in Switzerland?
Give a very brief answer. 2.48. What is the difference between the highest and the second highest Emissions (1000 metric ton of CO2 equivalent) of 1990?
Make the answer very short. 1933.4. What is the difference between the highest and the second highest Emissions (1000 metric ton of CO2 equivalent) in 2000?
Make the answer very short. 1003.1. What is the difference between the highest and the second highest Emissions (1000 metric ton of CO2 equivalent) in 2005?
Ensure brevity in your answer.  452.3. What is the difference between the highest and the second highest Emissions (1000 metric ton of CO2 equivalent) in 2008?
Your answer should be compact. 38.2. What is the difference between the highest and the lowest Emissions (1000 metric ton of CO2 equivalent) of 1990?
Provide a succinct answer. 2808.6. What is the difference between the highest and the lowest Emissions (1000 metric ton of CO2 equivalent) in 2000?
Ensure brevity in your answer.  2325.6. What is the difference between the highest and the lowest Emissions (1000 metric ton of CO2 equivalent) of 2005?
Ensure brevity in your answer.  1992.3. What is the difference between the highest and the lowest Emissions (1000 metric ton of CO2 equivalent) of 2008?
Provide a succinct answer. 1245.2. 